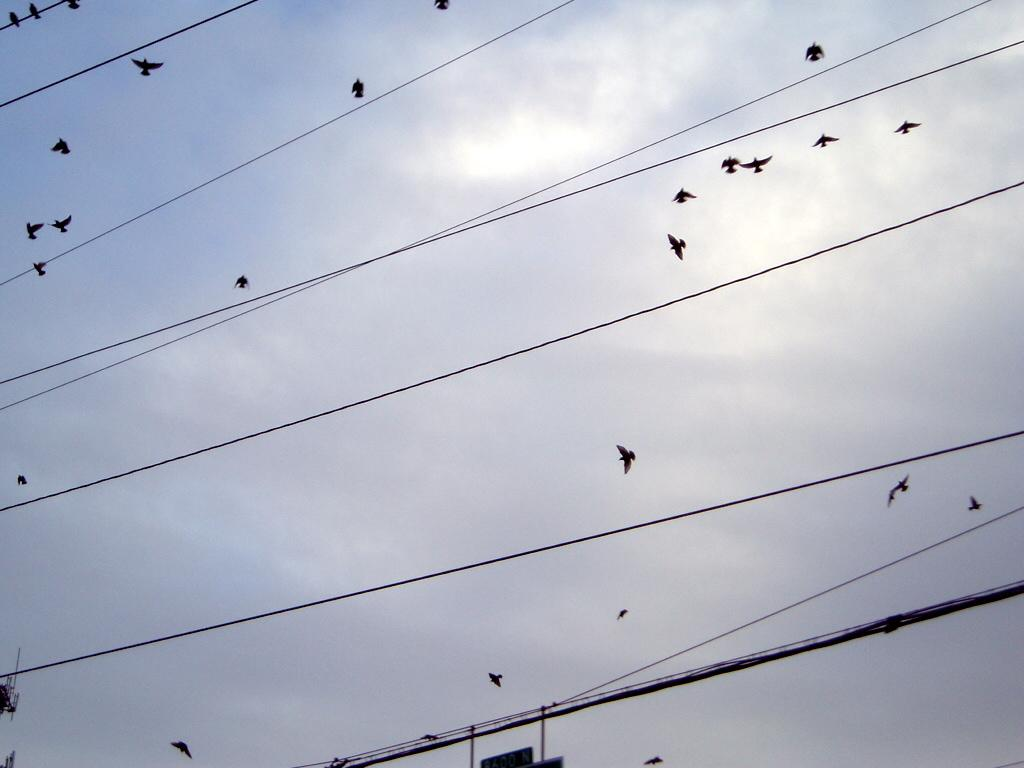What can be seen in the foreground of the image? There are cables in the foreground of the image. What is happening in the sky in the image? There are many birds in the air, and the sky is visible in the image. Can you describe the cloud in the sky? Yes, there is a cloud in the sky. What type of trees are being traded in the image? There are no trees or any indication of trade present in the image. How much lead can be seen in the image? There is no lead visible in the image. 